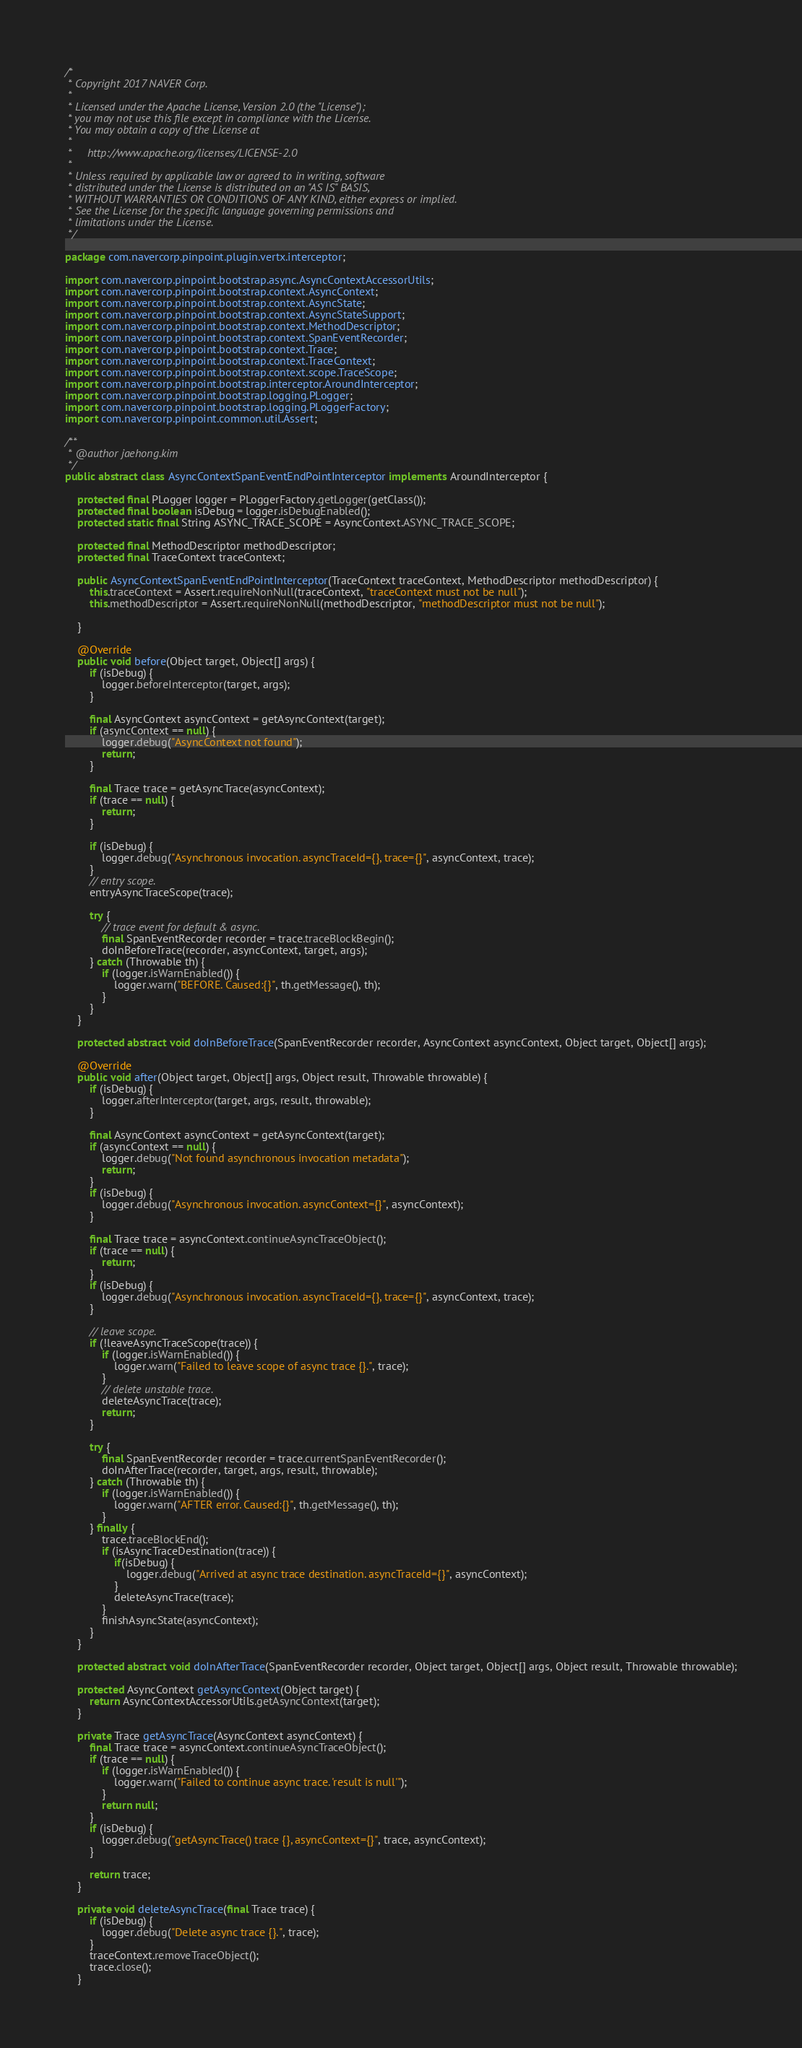<code> <loc_0><loc_0><loc_500><loc_500><_Java_>/*
 * Copyright 2017 NAVER Corp.
 *
 * Licensed under the Apache License, Version 2.0 (the "License");
 * you may not use this file except in compliance with the License.
 * You may obtain a copy of the License at
 *
 *     http://www.apache.org/licenses/LICENSE-2.0
 *
 * Unless required by applicable law or agreed to in writing, software
 * distributed under the License is distributed on an "AS IS" BASIS,
 * WITHOUT WARRANTIES OR CONDITIONS OF ANY KIND, either express or implied.
 * See the License for the specific language governing permissions and
 * limitations under the License.
 */

package com.navercorp.pinpoint.plugin.vertx.interceptor;

import com.navercorp.pinpoint.bootstrap.async.AsyncContextAccessorUtils;
import com.navercorp.pinpoint.bootstrap.context.AsyncContext;
import com.navercorp.pinpoint.bootstrap.context.AsyncState;
import com.navercorp.pinpoint.bootstrap.context.AsyncStateSupport;
import com.navercorp.pinpoint.bootstrap.context.MethodDescriptor;
import com.navercorp.pinpoint.bootstrap.context.SpanEventRecorder;
import com.navercorp.pinpoint.bootstrap.context.Trace;
import com.navercorp.pinpoint.bootstrap.context.TraceContext;
import com.navercorp.pinpoint.bootstrap.context.scope.TraceScope;
import com.navercorp.pinpoint.bootstrap.interceptor.AroundInterceptor;
import com.navercorp.pinpoint.bootstrap.logging.PLogger;
import com.navercorp.pinpoint.bootstrap.logging.PLoggerFactory;
import com.navercorp.pinpoint.common.util.Assert;

/**
 * @author jaehong.kim
 */
public abstract class AsyncContextSpanEventEndPointInterceptor implements AroundInterceptor {

    protected final PLogger logger = PLoggerFactory.getLogger(getClass());
    protected final boolean isDebug = logger.isDebugEnabled();
    protected static final String ASYNC_TRACE_SCOPE = AsyncContext.ASYNC_TRACE_SCOPE;

    protected final MethodDescriptor methodDescriptor;
    protected final TraceContext traceContext;

    public AsyncContextSpanEventEndPointInterceptor(TraceContext traceContext, MethodDescriptor methodDescriptor) {
        this.traceContext = Assert.requireNonNull(traceContext, "traceContext must not be null");
        this.methodDescriptor = Assert.requireNonNull(methodDescriptor, "methodDescriptor must not be null");

    }

    @Override
    public void before(Object target, Object[] args) {
        if (isDebug) {
            logger.beforeInterceptor(target, args);
        }

        final AsyncContext asyncContext = getAsyncContext(target);
        if (asyncContext == null) {
            logger.debug("AsyncContext not found");
            return;
        }

        final Trace trace = getAsyncTrace(asyncContext);
        if (trace == null) {
            return;
        }

        if (isDebug) {
            logger.debug("Asynchronous invocation. asyncTraceId={}, trace={}", asyncContext, trace);
        }
        // entry scope.
        entryAsyncTraceScope(trace);

        try {
            // trace event for default & async.
            final SpanEventRecorder recorder = trace.traceBlockBegin();
            doInBeforeTrace(recorder, asyncContext, target, args);
        } catch (Throwable th) {
            if (logger.isWarnEnabled()) {
                logger.warn("BEFORE. Caused:{}", th.getMessage(), th);
            }
        }
    }

    protected abstract void doInBeforeTrace(SpanEventRecorder recorder, AsyncContext asyncContext, Object target, Object[] args);

    @Override
    public void after(Object target, Object[] args, Object result, Throwable throwable) {
        if (isDebug) {
            logger.afterInterceptor(target, args, result, throwable);
        }

        final AsyncContext asyncContext = getAsyncContext(target);
        if (asyncContext == null) {
            logger.debug("Not found asynchronous invocation metadata");
            return;
        }
        if (isDebug) {
            logger.debug("Asynchronous invocation. asyncContext={}", asyncContext);
        }

        final Trace trace = asyncContext.continueAsyncTraceObject();
        if (trace == null) {
            return;
        }
        if (isDebug) {
            logger.debug("Asynchronous invocation. asyncTraceId={}, trace={}", asyncContext, trace);
        }

        // leave scope.
        if (!leaveAsyncTraceScope(trace)) {
            if (logger.isWarnEnabled()) {
                logger.warn("Failed to leave scope of async trace {}.", trace);
            }
            // delete unstable trace.
            deleteAsyncTrace(trace);
            return;
        }

        try {
            final SpanEventRecorder recorder = trace.currentSpanEventRecorder();
            doInAfterTrace(recorder, target, args, result, throwable);
        } catch (Throwable th) {
            if (logger.isWarnEnabled()) {
                logger.warn("AFTER error. Caused:{}", th.getMessage(), th);
            }
        } finally {
            trace.traceBlockEnd();
            if (isAsyncTraceDestination(trace)) {
                if(isDebug) {
                    logger.debug("Arrived at async trace destination. asyncTraceId={}", asyncContext);
                }
                deleteAsyncTrace(trace);
            }
            finishAsyncState(asyncContext);
        }
    }

    protected abstract void doInAfterTrace(SpanEventRecorder recorder, Object target, Object[] args, Object result, Throwable throwable);

    protected AsyncContext getAsyncContext(Object target) {
        return AsyncContextAccessorUtils.getAsyncContext(target);
    }

    private Trace getAsyncTrace(AsyncContext asyncContext) {
        final Trace trace = asyncContext.continueAsyncTraceObject();
        if (trace == null) {
            if (logger.isWarnEnabled()) {
                logger.warn("Failed to continue async trace. 'result is null'");
            }
            return null;
        }
        if (isDebug) {
            logger.debug("getAsyncTrace() trace {}, asyncContext={}", trace, asyncContext);
        }

        return trace;
    }

    private void deleteAsyncTrace(final Trace trace) {
        if (isDebug) {
            logger.debug("Delete async trace {}.", trace);
        }
        traceContext.removeTraceObject();
        trace.close();
    }
</code> 